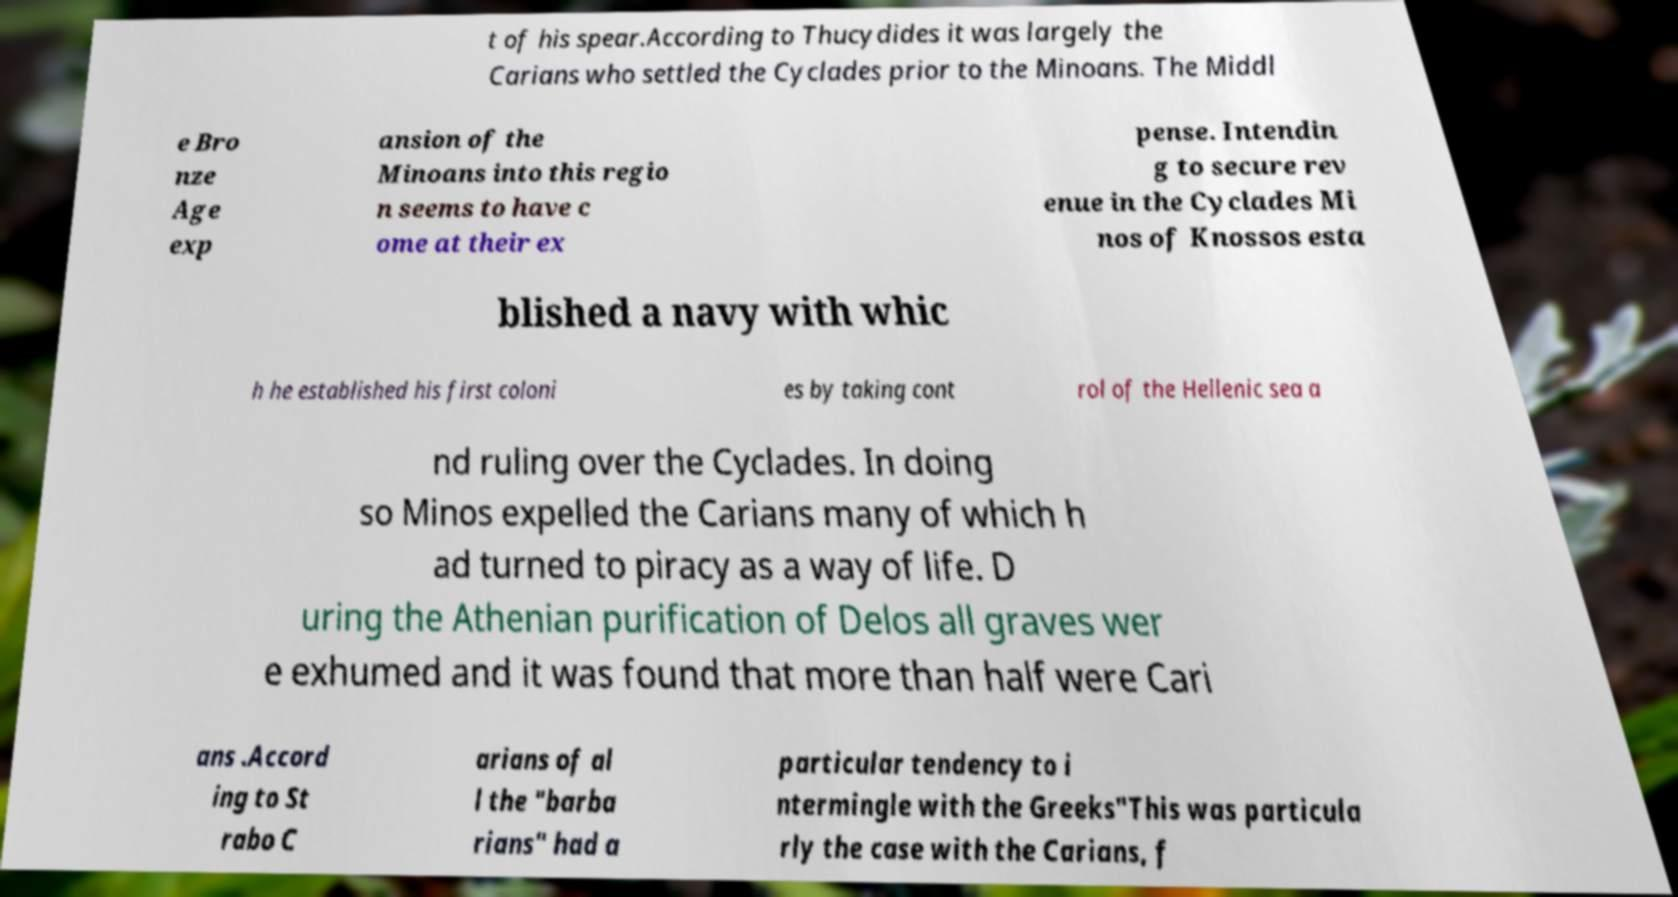What messages or text are displayed in this image? I need them in a readable, typed format. t of his spear.According to Thucydides it was largely the Carians who settled the Cyclades prior to the Minoans. The Middl e Bro nze Age exp ansion of the Minoans into this regio n seems to have c ome at their ex pense. Intendin g to secure rev enue in the Cyclades Mi nos of Knossos esta blished a navy with whic h he established his first coloni es by taking cont rol of the Hellenic sea a nd ruling over the Cyclades. In doing so Minos expelled the Carians many of which h ad turned to piracy as a way of life. D uring the Athenian purification of Delos all graves wer e exhumed and it was found that more than half were Cari ans .Accord ing to St rabo C arians of al l the "barba rians" had a particular tendency to i ntermingle with the Greeks"This was particula rly the case with the Carians, f 